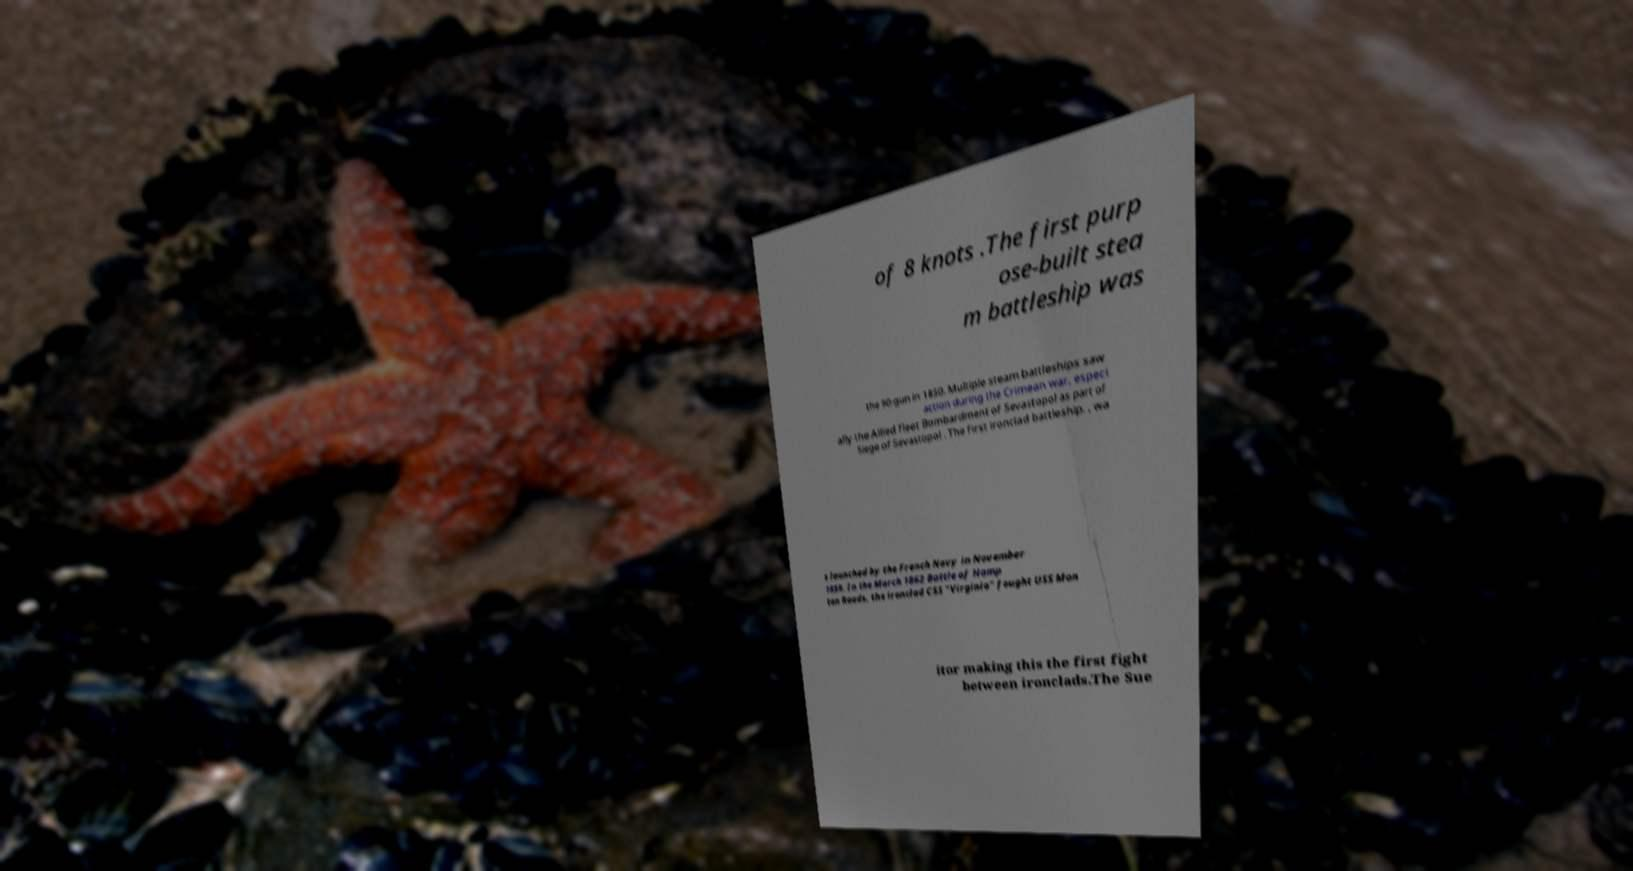I need the written content from this picture converted into text. Can you do that? of 8 knots .The first purp ose-built stea m battleship was the 90-gun in 1850. Multiple steam battleships saw action during the Crimean war, especi ally the Allied fleet Bombardment of Sevastopol as part of Siege of Sevastopol . The first ironclad battleship, , wa s launched by the French Navy in November 1859. In the March 1862 Battle of Hamp ton Roads, the ironclad CSS "Virginia" fought USS Mon itor making this the first fight between ironclads.The Sue 